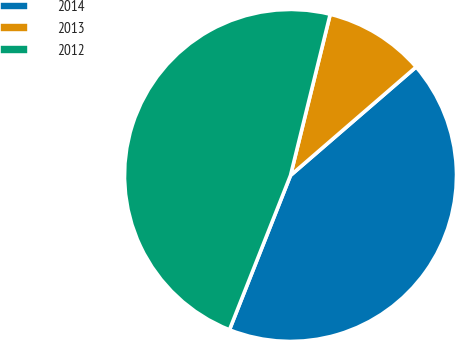<chart> <loc_0><loc_0><loc_500><loc_500><pie_chart><fcel>2014<fcel>2013<fcel>2012<nl><fcel>42.33%<fcel>9.82%<fcel>47.85%<nl></chart> 